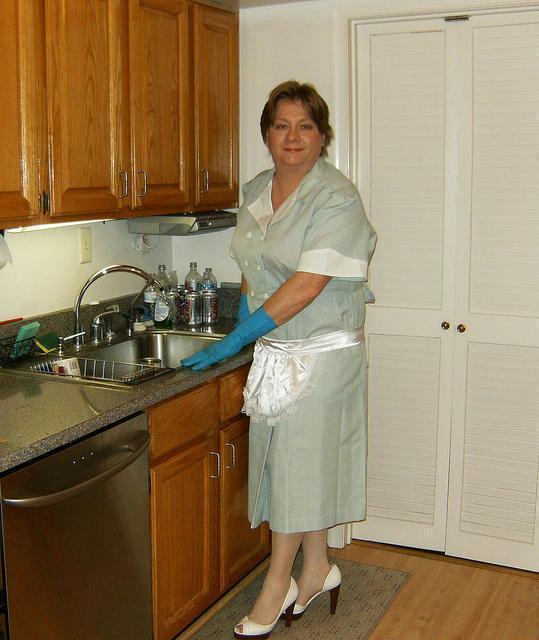Where may this lady be completing the cleaning?
Answer the question by selecting the correct answer among the 4 following choices and explain your choice with a short sentence. The answer should be formatted with the following format: `Answer: choice
Rationale: rationale.`
Options: Hotel, nursing home, residence, conference center. Answer: residence.
Rationale: This looks like a room that is found in a house in a residential home. 